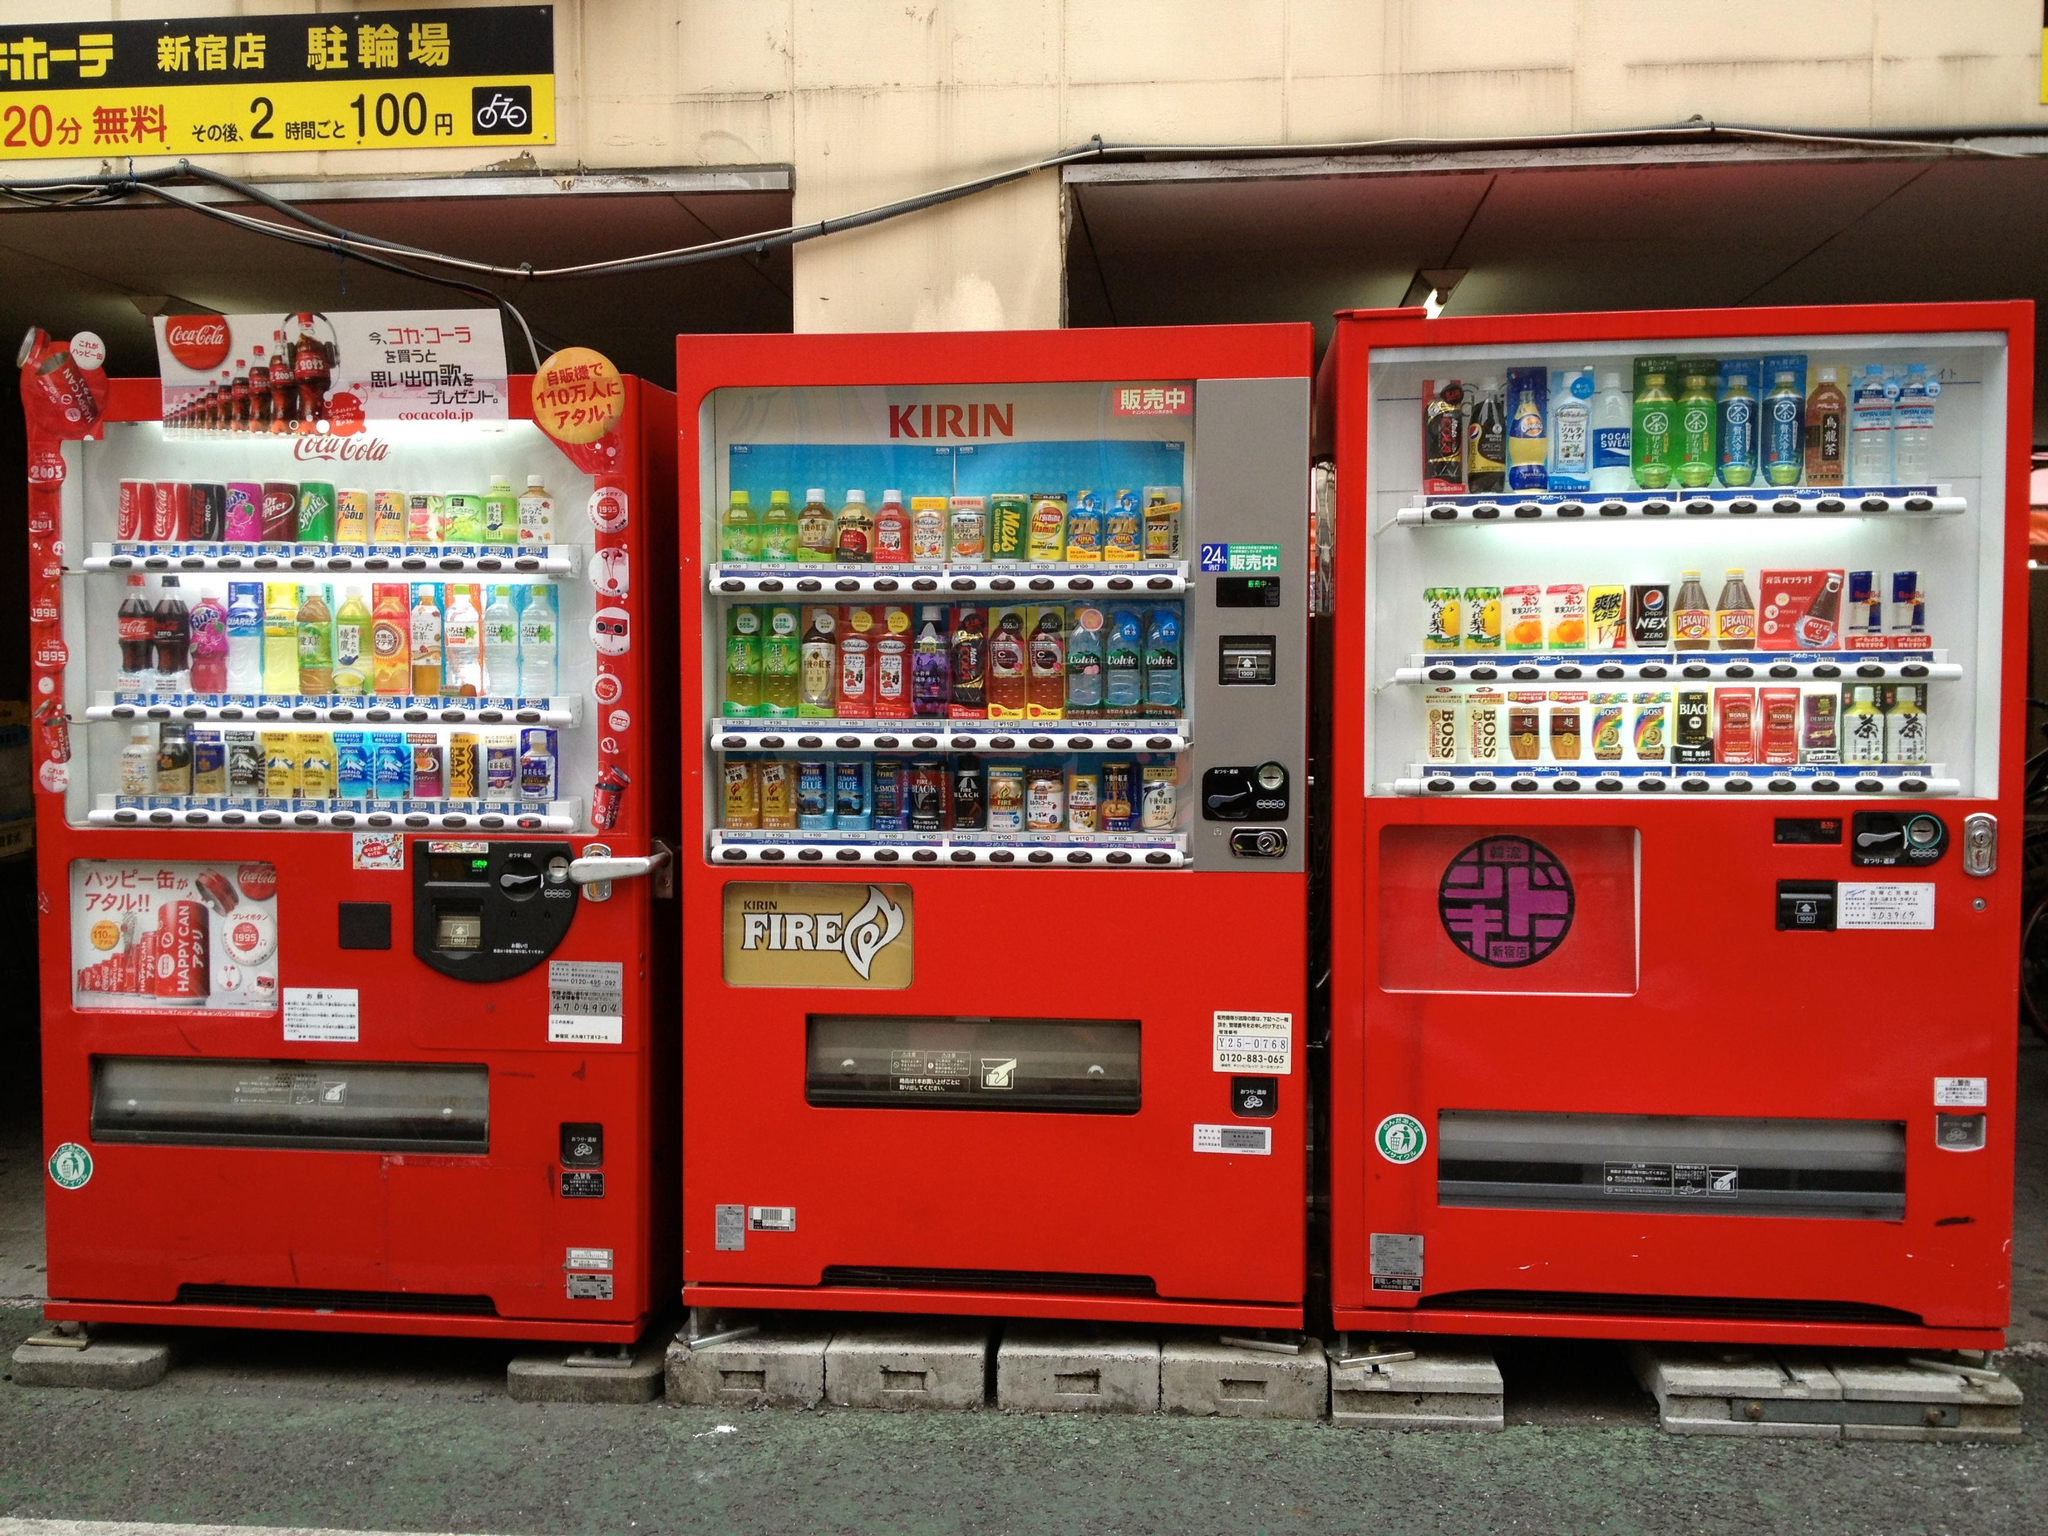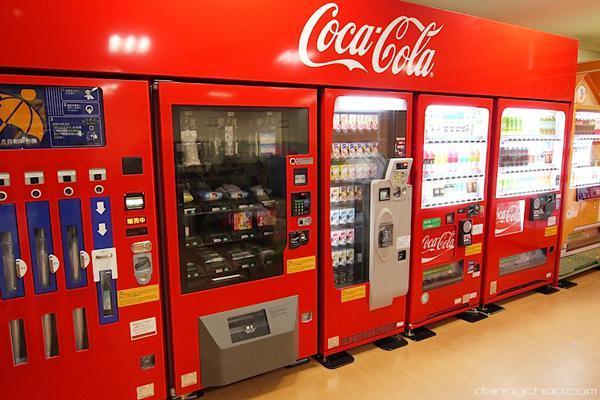The first image is the image on the left, the second image is the image on the right. Evaluate the accuracy of this statement regarding the images: "An image shows a row of red, white and blue vending machines.". Is it true? Answer yes or no. No. The first image is the image on the left, the second image is the image on the right. Examine the images to the left and right. Is the description "At least one of the machines is bright red." accurate? Answer yes or no. Yes. 